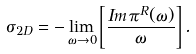Convert formula to latex. <formula><loc_0><loc_0><loc_500><loc_500>\sigma _ { 2 D } = - \lim _ { \omega \rightarrow 0 } \left [ \frac { I m \, \pi ^ { R } ( \omega ) } { \omega } \right ] .</formula> 